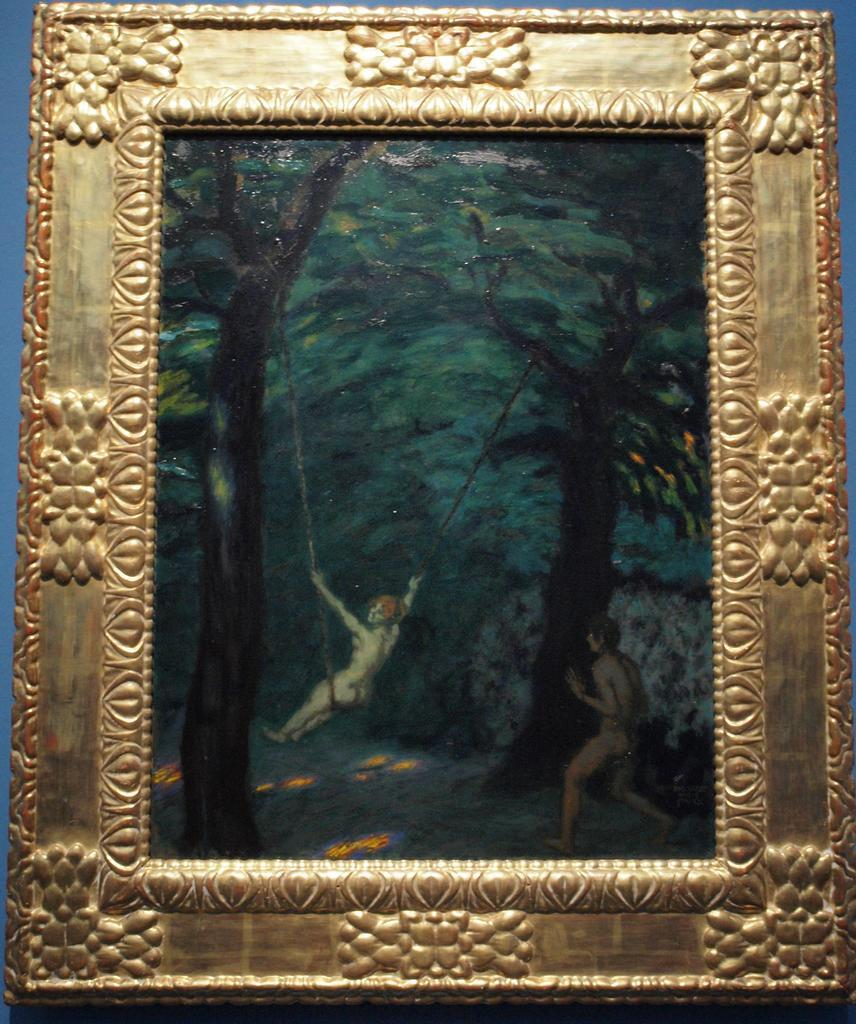What object is present in the image that typically holds a photo? There is a photo frame in the image. What is inside the photo frame? The photo frame contains a photo. How many people are in the photo? There are two persons in the photo. What type of natural scenery can be seen in the photo? There are trees in the photo. What type of stocking is hanging from the tree in the photo? There is no stocking hanging from the tree in the photo; it only shows trees and no other objects or people. 